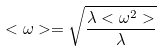Convert formula to latex. <formula><loc_0><loc_0><loc_500><loc_500>< \omega > = \sqrt { \frac { \lambda < \omega ^ { 2 } > } { \lambda } }</formula> 